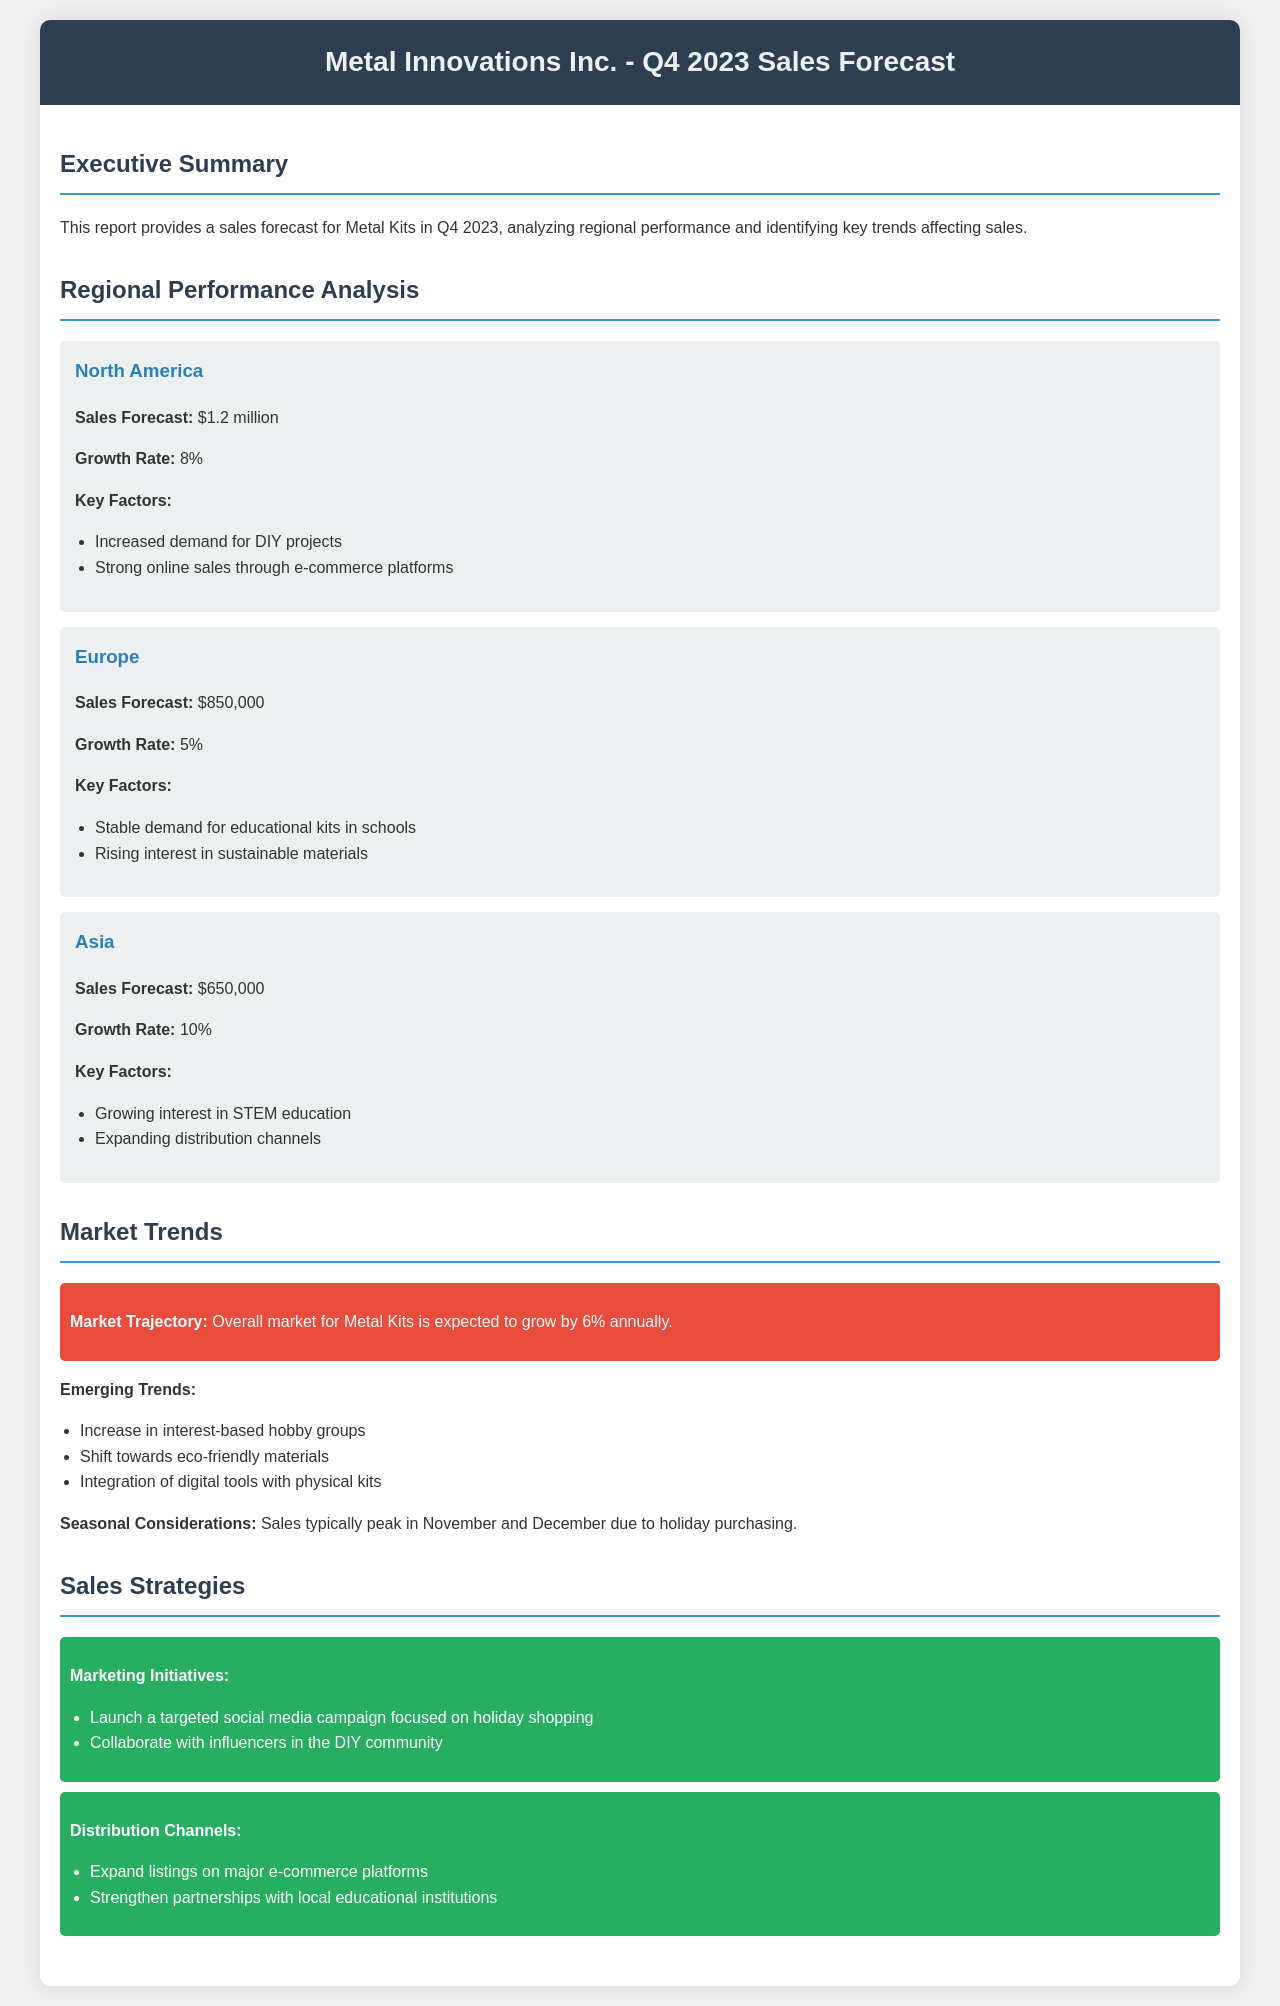What is the sales forecast for North America? The sales forecast for North America is presented as $1.2 million in the regional performance analysis section.
Answer: $1.2 million What is the growth rate for Europe? The growth rate for Europe is indicated as 5% in the document's analysis of regional performance.
Answer: 5% What are the key factors driving sales in Asia? Key factors driving sales in Asia are listed, specifically "Growing interest in STEM education" and "Expanding distribution channels."
Answer: Growing interest in STEM education, Expanding distribution channels What is the expected annual market growth rate for Metal Kits? The document states that the overall market for Metal Kits is expected to grow by 6% annually in the market trends section.
Answer: 6% What is one of the emerging trends mentioned in the report? One emerging trend mentioned is "Increase in interest-based hobby groups," indicating a shift in consumer behavior towards hobby activities.
Answer: Increase in interest-based hobby groups How does the sales typically peak during the year? The document notes that sales typically peak in November and December due to holiday purchasing, indicating a seasonal trend.
Answer: November and December What marketing initiative is recommended in the sales strategies? The recommended marketing initiative is to "launch a targeted social media campaign focused on holiday shopping."
Answer: Launch a targeted social media campaign What sales forecast amount is projected for Asia? The sales forecast amount projected for Asia is denoted as $650,000 in the section discussing regional performance.
Answer: $650,000 What is the forecasted growth rate for North America? The growth rate for North America is mentioned as 8%, showcasing a positive trend in that region.
Answer: 8% 